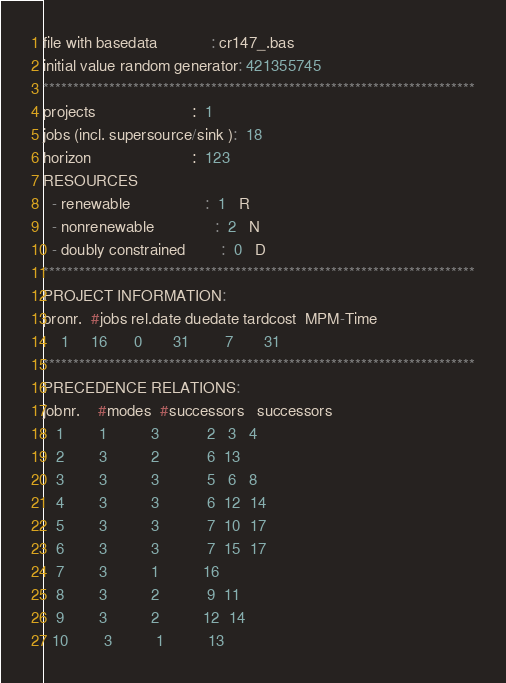<code> <loc_0><loc_0><loc_500><loc_500><_ObjectiveC_>file with basedata            : cr147_.bas
initial value random generator: 421355745
************************************************************************
projects                      :  1
jobs (incl. supersource/sink ):  18
horizon                       :  123
RESOURCES
  - renewable                 :  1   R
  - nonrenewable              :  2   N
  - doubly constrained        :  0   D
************************************************************************
PROJECT INFORMATION:
pronr.  #jobs rel.date duedate tardcost  MPM-Time
    1     16      0       31        7       31
************************************************************************
PRECEDENCE RELATIONS:
jobnr.    #modes  #successors   successors
   1        1          3           2   3   4
   2        3          2           6  13
   3        3          3           5   6   8
   4        3          3           6  12  14
   5        3          3           7  10  17
   6        3          3           7  15  17
   7        3          1          16
   8        3          2           9  11
   9        3          2          12  14
  10        3          1          13</code> 